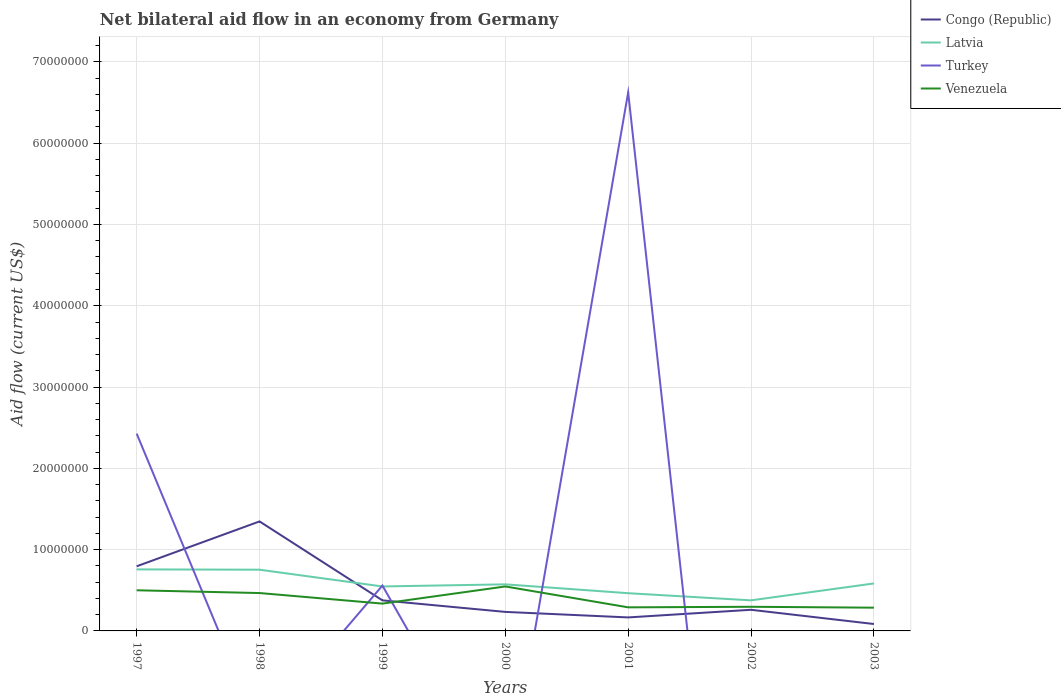Does the line corresponding to Latvia intersect with the line corresponding to Venezuela?
Offer a very short reply. No. Across all years, what is the maximum net bilateral aid flow in Latvia?
Make the answer very short. 3.76e+06. What is the total net bilateral aid flow in Venezuela in the graph?
Make the answer very short. 2.57e+06. What is the difference between the highest and the second highest net bilateral aid flow in Venezuela?
Your response must be concise. 2.61e+06. What is the difference between the highest and the lowest net bilateral aid flow in Congo (Republic)?
Make the answer very short. 2. Is the net bilateral aid flow in Venezuela strictly greater than the net bilateral aid flow in Congo (Republic) over the years?
Your answer should be very brief. No. Are the values on the major ticks of Y-axis written in scientific E-notation?
Provide a short and direct response. No. Where does the legend appear in the graph?
Your answer should be compact. Top right. What is the title of the graph?
Keep it short and to the point. Net bilateral aid flow in an economy from Germany. Does "Italy" appear as one of the legend labels in the graph?
Make the answer very short. No. What is the label or title of the Y-axis?
Ensure brevity in your answer.  Aid flow (current US$). What is the Aid flow (current US$) in Congo (Republic) in 1997?
Make the answer very short. 7.95e+06. What is the Aid flow (current US$) in Latvia in 1997?
Offer a terse response. 7.57e+06. What is the Aid flow (current US$) in Turkey in 1997?
Offer a terse response. 2.43e+07. What is the Aid flow (current US$) in Venezuela in 1997?
Provide a short and direct response. 5.00e+06. What is the Aid flow (current US$) in Congo (Republic) in 1998?
Ensure brevity in your answer.  1.35e+07. What is the Aid flow (current US$) in Latvia in 1998?
Provide a short and direct response. 7.53e+06. What is the Aid flow (current US$) of Turkey in 1998?
Your response must be concise. 0. What is the Aid flow (current US$) of Venezuela in 1998?
Give a very brief answer. 4.66e+06. What is the Aid flow (current US$) of Congo (Republic) in 1999?
Provide a succinct answer. 3.76e+06. What is the Aid flow (current US$) in Latvia in 1999?
Give a very brief answer. 5.47e+06. What is the Aid flow (current US$) in Turkey in 1999?
Your answer should be very brief. 5.58e+06. What is the Aid flow (current US$) of Venezuela in 1999?
Make the answer very short. 3.36e+06. What is the Aid flow (current US$) in Congo (Republic) in 2000?
Provide a short and direct response. 2.34e+06. What is the Aid flow (current US$) in Latvia in 2000?
Make the answer very short. 5.73e+06. What is the Aid flow (current US$) of Turkey in 2000?
Your response must be concise. 0. What is the Aid flow (current US$) in Venezuela in 2000?
Keep it short and to the point. 5.47e+06. What is the Aid flow (current US$) in Congo (Republic) in 2001?
Provide a succinct answer. 1.66e+06. What is the Aid flow (current US$) in Latvia in 2001?
Provide a succinct answer. 4.64e+06. What is the Aid flow (current US$) of Turkey in 2001?
Your response must be concise. 6.62e+07. What is the Aid flow (current US$) in Venezuela in 2001?
Provide a succinct answer. 2.90e+06. What is the Aid flow (current US$) in Congo (Republic) in 2002?
Your answer should be very brief. 2.60e+06. What is the Aid flow (current US$) of Latvia in 2002?
Your answer should be compact. 3.76e+06. What is the Aid flow (current US$) of Turkey in 2002?
Your answer should be very brief. 0. What is the Aid flow (current US$) in Venezuela in 2002?
Your answer should be compact. 2.97e+06. What is the Aid flow (current US$) in Congo (Republic) in 2003?
Your answer should be very brief. 8.50e+05. What is the Aid flow (current US$) of Latvia in 2003?
Your answer should be compact. 5.84e+06. What is the Aid flow (current US$) of Turkey in 2003?
Provide a succinct answer. 0. What is the Aid flow (current US$) of Venezuela in 2003?
Offer a terse response. 2.86e+06. Across all years, what is the maximum Aid flow (current US$) in Congo (Republic)?
Offer a terse response. 1.35e+07. Across all years, what is the maximum Aid flow (current US$) in Latvia?
Ensure brevity in your answer.  7.57e+06. Across all years, what is the maximum Aid flow (current US$) of Turkey?
Your response must be concise. 6.62e+07. Across all years, what is the maximum Aid flow (current US$) of Venezuela?
Offer a terse response. 5.47e+06. Across all years, what is the minimum Aid flow (current US$) of Congo (Republic)?
Provide a succinct answer. 8.50e+05. Across all years, what is the minimum Aid flow (current US$) in Latvia?
Your response must be concise. 3.76e+06. Across all years, what is the minimum Aid flow (current US$) of Turkey?
Your response must be concise. 0. Across all years, what is the minimum Aid flow (current US$) of Venezuela?
Ensure brevity in your answer.  2.86e+06. What is the total Aid flow (current US$) of Congo (Republic) in the graph?
Keep it short and to the point. 3.26e+07. What is the total Aid flow (current US$) of Latvia in the graph?
Give a very brief answer. 4.05e+07. What is the total Aid flow (current US$) in Turkey in the graph?
Your response must be concise. 9.61e+07. What is the total Aid flow (current US$) in Venezuela in the graph?
Give a very brief answer. 2.72e+07. What is the difference between the Aid flow (current US$) in Congo (Republic) in 1997 and that in 1998?
Provide a short and direct response. -5.52e+06. What is the difference between the Aid flow (current US$) in Venezuela in 1997 and that in 1998?
Ensure brevity in your answer.  3.40e+05. What is the difference between the Aid flow (current US$) in Congo (Republic) in 1997 and that in 1999?
Your response must be concise. 4.19e+06. What is the difference between the Aid flow (current US$) of Latvia in 1997 and that in 1999?
Provide a succinct answer. 2.10e+06. What is the difference between the Aid flow (current US$) in Turkey in 1997 and that in 1999?
Offer a terse response. 1.87e+07. What is the difference between the Aid flow (current US$) in Venezuela in 1997 and that in 1999?
Your answer should be compact. 1.64e+06. What is the difference between the Aid flow (current US$) in Congo (Republic) in 1997 and that in 2000?
Your answer should be compact. 5.61e+06. What is the difference between the Aid flow (current US$) in Latvia in 1997 and that in 2000?
Your answer should be compact. 1.84e+06. What is the difference between the Aid flow (current US$) in Venezuela in 1997 and that in 2000?
Your response must be concise. -4.70e+05. What is the difference between the Aid flow (current US$) in Congo (Republic) in 1997 and that in 2001?
Provide a short and direct response. 6.29e+06. What is the difference between the Aid flow (current US$) of Latvia in 1997 and that in 2001?
Keep it short and to the point. 2.93e+06. What is the difference between the Aid flow (current US$) in Turkey in 1997 and that in 2001?
Offer a terse response. -4.20e+07. What is the difference between the Aid flow (current US$) of Venezuela in 1997 and that in 2001?
Provide a short and direct response. 2.10e+06. What is the difference between the Aid flow (current US$) in Congo (Republic) in 1997 and that in 2002?
Your answer should be compact. 5.35e+06. What is the difference between the Aid flow (current US$) of Latvia in 1997 and that in 2002?
Provide a succinct answer. 3.81e+06. What is the difference between the Aid flow (current US$) in Venezuela in 1997 and that in 2002?
Your answer should be compact. 2.03e+06. What is the difference between the Aid flow (current US$) in Congo (Republic) in 1997 and that in 2003?
Your answer should be very brief. 7.10e+06. What is the difference between the Aid flow (current US$) of Latvia in 1997 and that in 2003?
Your answer should be very brief. 1.73e+06. What is the difference between the Aid flow (current US$) of Venezuela in 1997 and that in 2003?
Give a very brief answer. 2.14e+06. What is the difference between the Aid flow (current US$) of Congo (Republic) in 1998 and that in 1999?
Offer a terse response. 9.71e+06. What is the difference between the Aid flow (current US$) of Latvia in 1998 and that in 1999?
Your response must be concise. 2.06e+06. What is the difference between the Aid flow (current US$) of Venezuela in 1998 and that in 1999?
Your answer should be compact. 1.30e+06. What is the difference between the Aid flow (current US$) in Congo (Republic) in 1998 and that in 2000?
Your answer should be very brief. 1.11e+07. What is the difference between the Aid flow (current US$) in Latvia in 1998 and that in 2000?
Make the answer very short. 1.80e+06. What is the difference between the Aid flow (current US$) in Venezuela in 1998 and that in 2000?
Your answer should be compact. -8.10e+05. What is the difference between the Aid flow (current US$) of Congo (Republic) in 1998 and that in 2001?
Your answer should be very brief. 1.18e+07. What is the difference between the Aid flow (current US$) of Latvia in 1998 and that in 2001?
Your response must be concise. 2.89e+06. What is the difference between the Aid flow (current US$) of Venezuela in 1998 and that in 2001?
Provide a succinct answer. 1.76e+06. What is the difference between the Aid flow (current US$) of Congo (Republic) in 1998 and that in 2002?
Give a very brief answer. 1.09e+07. What is the difference between the Aid flow (current US$) of Latvia in 1998 and that in 2002?
Provide a short and direct response. 3.77e+06. What is the difference between the Aid flow (current US$) of Venezuela in 1998 and that in 2002?
Offer a very short reply. 1.69e+06. What is the difference between the Aid flow (current US$) of Congo (Republic) in 1998 and that in 2003?
Make the answer very short. 1.26e+07. What is the difference between the Aid flow (current US$) in Latvia in 1998 and that in 2003?
Ensure brevity in your answer.  1.69e+06. What is the difference between the Aid flow (current US$) of Venezuela in 1998 and that in 2003?
Provide a succinct answer. 1.80e+06. What is the difference between the Aid flow (current US$) of Congo (Republic) in 1999 and that in 2000?
Make the answer very short. 1.42e+06. What is the difference between the Aid flow (current US$) in Latvia in 1999 and that in 2000?
Make the answer very short. -2.60e+05. What is the difference between the Aid flow (current US$) of Venezuela in 1999 and that in 2000?
Provide a short and direct response. -2.11e+06. What is the difference between the Aid flow (current US$) of Congo (Republic) in 1999 and that in 2001?
Keep it short and to the point. 2.10e+06. What is the difference between the Aid flow (current US$) in Latvia in 1999 and that in 2001?
Offer a terse response. 8.30e+05. What is the difference between the Aid flow (current US$) of Turkey in 1999 and that in 2001?
Your response must be concise. -6.07e+07. What is the difference between the Aid flow (current US$) in Venezuela in 1999 and that in 2001?
Your answer should be very brief. 4.60e+05. What is the difference between the Aid flow (current US$) in Congo (Republic) in 1999 and that in 2002?
Provide a short and direct response. 1.16e+06. What is the difference between the Aid flow (current US$) in Latvia in 1999 and that in 2002?
Your response must be concise. 1.71e+06. What is the difference between the Aid flow (current US$) of Venezuela in 1999 and that in 2002?
Provide a short and direct response. 3.90e+05. What is the difference between the Aid flow (current US$) in Congo (Republic) in 1999 and that in 2003?
Your response must be concise. 2.91e+06. What is the difference between the Aid flow (current US$) in Latvia in 1999 and that in 2003?
Offer a terse response. -3.70e+05. What is the difference between the Aid flow (current US$) in Venezuela in 1999 and that in 2003?
Give a very brief answer. 5.00e+05. What is the difference between the Aid flow (current US$) in Congo (Republic) in 2000 and that in 2001?
Your answer should be very brief. 6.80e+05. What is the difference between the Aid flow (current US$) in Latvia in 2000 and that in 2001?
Your response must be concise. 1.09e+06. What is the difference between the Aid flow (current US$) in Venezuela in 2000 and that in 2001?
Ensure brevity in your answer.  2.57e+06. What is the difference between the Aid flow (current US$) of Latvia in 2000 and that in 2002?
Keep it short and to the point. 1.97e+06. What is the difference between the Aid flow (current US$) of Venezuela in 2000 and that in 2002?
Your answer should be compact. 2.50e+06. What is the difference between the Aid flow (current US$) of Congo (Republic) in 2000 and that in 2003?
Make the answer very short. 1.49e+06. What is the difference between the Aid flow (current US$) of Venezuela in 2000 and that in 2003?
Make the answer very short. 2.61e+06. What is the difference between the Aid flow (current US$) in Congo (Republic) in 2001 and that in 2002?
Offer a very short reply. -9.40e+05. What is the difference between the Aid flow (current US$) in Latvia in 2001 and that in 2002?
Keep it short and to the point. 8.80e+05. What is the difference between the Aid flow (current US$) in Congo (Republic) in 2001 and that in 2003?
Your answer should be compact. 8.10e+05. What is the difference between the Aid flow (current US$) in Latvia in 2001 and that in 2003?
Give a very brief answer. -1.20e+06. What is the difference between the Aid flow (current US$) in Venezuela in 2001 and that in 2003?
Make the answer very short. 4.00e+04. What is the difference between the Aid flow (current US$) in Congo (Republic) in 2002 and that in 2003?
Your answer should be very brief. 1.75e+06. What is the difference between the Aid flow (current US$) in Latvia in 2002 and that in 2003?
Make the answer very short. -2.08e+06. What is the difference between the Aid flow (current US$) of Congo (Republic) in 1997 and the Aid flow (current US$) of Latvia in 1998?
Ensure brevity in your answer.  4.20e+05. What is the difference between the Aid flow (current US$) in Congo (Republic) in 1997 and the Aid flow (current US$) in Venezuela in 1998?
Offer a very short reply. 3.29e+06. What is the difference between the Aid flow (current US$) of Latvia in 1997 and the Aid flow (current US$) of Venezuela in 1998?
Your answer should be compact. 2.91e+06. What is the difference between the Aid flow (current US$) in Turkey in 1997 and the Aid flow (current US$) in Venezuela in 1998?
Your answer should be compact. 1.96e+07. What is the difference between the Aid flow (current US$) of Congo (Republic) in 1997 and the Aid flow (current US$) of Latvia in 1999?
Provide a short and direct response. 2.48e+06. What is the difference between the Aid flow (current US$) in Congo (Republic) in 1997 and the Aid flow (current US$) in Turkey in 1999?
Make the answer very short. 2.37e+06. What is the difference between the Aid flow (current US$) in Congo (Republic) in 1997 and the Aid flow (current US$) in Venezuela in 1999?
Offer a very short reply. 4.59e+06. What is the difference between the Aid flow (current US$) in Latvia in 1997 and the Aid flow (current US$) in Turkey in 1999?
Give a very brief answer. 1.99e+06. What is the difference between the Aid flow (current US$) of Latvia in 1997 and the Aid flow (current US$) of Venezuela in 1999?
Your response must be concise. 4.21e+06. What is the difference between the Aid flow (current US$) in Turkey in 1997 and the Aid flow (current US$) in Venezuela in 1999?
Provide a short and direct response. 2.09e+07. What is the difference between the Aid flow (current US$) in Congo (Republic) in 1997 and the Aid flow (current US$) in Latvia in 2000?
Provide a short and direct response. 2.22e+06. What is the difference between the Aid flow (current US$) in Congo (Republic) in 1997 and the Aid flow (current US$) in Venezuela in 2000?
Offer a terse response. 2.48e+06. What is the difference between the Aid flow (current US$) of Latvia in 1997 and the Aid flow (current US$) of Venezuela in 2000?
Your answer should be very brief. 2.10e+06. What is the difference between the Aid flow (current US$) in Turkey in 1997 and the Aid flow (current US$) in Venezuela in 2000?
Ensure brevity in your answer.  1.88e+07. What is the difference between the Aid flow (current US$) of Congo (Republic) in 1997 and the Aid flow (current US$) of Latvia in 2001?
Offer a very short reply. 3.31e+06. What is the difference between the Aid flow (current US$) of Congo (Republic) in 1997 and the Aid flow (current US$) of Turkey in 2001?
Provide a short and direct response. -5.83e+07. What is the difference between the Aid flow (current US$) of Congo (Republic) in 1997 and the Aid flow (current US$) of Venezuela in 2001?
Ensure brevity in your answer.  5.05e+06. What is the difference between the Aid flow (current US$) in Latvia in 1997 and the Aid flow (current US$) in Turkey in 2001?
Your answer should be very brief. -5.87e+07. What is the difference between the Aid flow (current US$) in Latvia in 1997 and the Aid flow (current US$) in Venezuela in 2001?
Keep it short and to the point. 4.67e+06. What is the difference between the Aid flow (current US$) of Turkey in 1997 and the Aid flow (current US$) of Venezuela in 2001?
Your answer should be very brief. 2.14e+07. What is the difference between the Aid flow (current US$) in Congo (Republic) in 1997 and the Aid flow (current US$) in Latvia in 2002?
Your answer should be compact. 4.19e+06. What is the difference between the Aid flow (current US$) of Congo (Republic) in 1997 and the Aid flow (current US$) of Venezuela in 2002?
Provide a short and direct response. 4.98e+06. What is the difference between the Aid flow (current US$) of Latvia in 1997 and the Aid flow (current US$) of Venezuela in 2002?
Make the answer very short. 4.60e+06. What is the difference between the Aid flow (current US$) of Turkey in 1997 and the Aid flow (current US$) of Venezuela in 2002?
Keep it short and to the point. 2.13e+07. What is the difference between the Aid flow (current US$) in Congo (Republic) in 1997 and the Aid flow (current US$) in Latvia in 2003?
Give a very brief answer. 2.11e+06. What is the difference between the Aid flow (current US$) in Congo (Republic) in 1997 and the Aid flow (current US$) in Venezuela in 2003?
Your answer should be very brief. 5.09e+06. What is the difference between the Aid flow (current US$) in Latvia in 1997 and the Aid flow (current US$) in Venezuela in 2003?
Your response must be concise. 4.71e+06. What is the difference between the Aid flow (current US$) in Turkey in 1997 and the Aid flow (current US$) in Venezuela in 2003?
Provide a short and direct response. 2.14e+07. What is the difference between the Aid flow (current US$) in Congo (Republic) in 1998 and the Aid flow (current US$) in Latvia in 1999?
Give a very brief answer. 8.00e+06. What is the difference between the Aid flow (current US$) of Congo (Republic) in 1998 and the Aid flow (current US$) of Turkey in 1999?
Offer a terse response. 7.89e+06. What is the difference between the Aid flow (current US$) of Congo (Republic) in 1998 and the Aid flow (current US$) of Venezuela in 1999?
Ensure brevity in your answer.  1.01e+07. What is the difference between the Aid flow (current US$) of Latvia in 1998 and the Aid flow (current US$) of Turkey in 1999?
Provide a short and direct response. 1.95e+06. What is the difference between the Aid flow (current US$) of Latvia in 1998 and the Aid flow (current US$) of Venezuela in 1999?
Keep it short and to the point. 4.17e+06. What is the difference between the Aid flow (current US$) of Congo (Republic) in 1998 and the Aid flow (current US$) of Latvia in 2000?
Your answer should be compact. 7.74e+06. What is the difference between the Aid flow (current US$) of Congo (Republic) in 1998 and the Aid flow (current US$) of Venezuela in 2000?
Offer a very short reply. 8.00e+06. What is the difference between the Aid flow (current US$) of Latvia in 1998 and the Aid flow (current US$) of Venezuela in 2000?
Give a very brief answer. 2.06e+06. What is the difference between the Aid flow (current US$) in Congo (Republic) in 1998 and the Aid flow (current US$) in Latvia in 2001?
Make the answer very short. 8.83e+06. What is the difference between the Aid flow (current US$) in Congo (Republic) in 1998 and the Aid flow (current US$) in Turkey in 2001?
Make the answer very short. -5.28e+07. What is the difference between the Aid flow (current US$) of Congo (Republic) in 1998 and the Aid flow (current US$) of Venezuela in 2001?
Your answer should be very brief. 1.06e+07. What is the difference between the Aid flow (current US$) of Latvia in 1998 and the Aid flow (current US$) of Turkey in 2001?
Give a very brief answer. -5.87e+07. What is the difference between the Aid flow (current US$) in Latvia in 1998 and the Aid flow (current US$) in Venezuela in 2001?
Ensure brevity in your answer.  4.63e+06. What is the difference between the Aid flow (current US$) of Congo (Republic) in 1998 and the Aid flow (current US$) of Latvia in 2002?
Make the answer very short. 9.71e+06. What is the difference between the Aid flow (current US$) in Congo (Republic) in 1998 and the Aid flow (current US$) in Venezuela in 2002?
Ensure brevity in your answer.  1.05e+07. What is the difference between the Aid flow (current US$) in Latvia in 1998 and the Aid flow (current US$) in Venezuela in 2002?
Your answer should be very brief. 4.56e+06. What is the difference between the Aid flow (current US$) of Congo (Republic) in 1998 and the Aid flow (current US$) of Latvia in 2003?
Your answer should be very brief. 7.63e+06. What is the difference between the Aid flow (current US$) of Congo (Republic) in 1998 and the Aid flow (current US$) of Venezuela in 2003?
Offer a very short reply. 1.06e+07. What is the difference between the Aid flow (current US$) in Latvia in 1998 and the Aid flow (current US$) in Venezuela in 2003?
Ensure brevity in your answer.  4.67e+06. What is the difference between the Aid flow (current US$) in Congo (Republic) in 1999 and the Aid flow (current US$) in Latvia in 2000?
Offer a terse response. -1.97e+06. What is the difference between the Aid flow (current US$) in Congo (Republic) in 1999 and the Aid flow (current US$) in Venezuela in 2000?
Provide a short and direct response. -1.71e+06. What is the difference between the Aid flow (current US$) of Latvia in 1999 and the Aid flow (current US$) of Venezuela in 2000?
Provide a succinct answer. 0. What is the difference between the Aid flow (current US$) of Turkey in 1999 and the Aid flow (current US$) of Venezuela in 2000?
Your answer should be very brief. 1.10e+05. What is the difference between the Aid flow (current US$) of Congo (Republic) in 1999 and the Aid flow (current US$) of Latvia in 2001?
Your response must be concise. -8.80e+05. What is the difference between the Aid flow (current US$) of Congo (Republic) in 1999 and the Aid flow (current US$) of Turkey in 2001?
Offer a very short reply. -6.25e+07. What is the difference between the Aid flow (current US$) in Congo (Republic) in 1999 and the Aid flow (current US$) in Venezuela in 2001?
Offer a very short reply. 8.60e+05. What is the difference between the Aid flow (current US$) of Latvia in 1999 and the Aid flow (current US$) of Turkey in 2001?
Your answer should be compact. -6.08e+07. What is the difference between the Aid flow (current US$) in Latvia in 1999 and the Aid flow (current US$) in Venezuela in 2001?
Your answer should be compact. 2.57e+06. What is the difference between the Aid flow (current US$) in Turkey in 1999 and the Aid flow (current US$) in Venezuela in 2001?
Your answer should be very brief. 2.68e+06. What is the difference between the Aid flow (current US$) of Congo (Republic) in 1999 and the Aid flow (current US$) of Latvia in 2002?
Ensure brevity in your answer.  0. What is the difference between the Aid flow (current US$) in Congo (Republic) in 1999 and the Aid flow (current US$) in Venezuela in 2002?
Keep it short and to the point. 7.90e+05. What is the difference between the Aid flow (current US$) in Latvia in 1999 and the Aid flow (current US$) in Venezuela in 2002?
Your answer should be compact. 2.50e+06. What is the difference between the Aid flow (current US$) in Turkey in 1999 and the Aid flow (current US$) in Venezuela in 2002?
Offer a terse response. 2.61e+06. What is the difference between the Aid flow (current US$) of Congo (Republic) in 1999 and the Aid flow (current US$) of Latvia in 2003?
Your answer should be compact. -2.08e+06. What is the difference between the Aid flow (current US$) of Latvia in 1999 and the Aid flow (current US$) of Venezuela in 2003?
Your answer should be compact. 2.61e+06. What is the difference between the Aid flow (current US$) of Turkey in 1999 and the Aid flow (current US$) of Venezuela in 2003?
Provide a short and direct response. 2.72e+06. What is the difference between the Aid flow (current US$) of Congo (Republic) in 2000 and the Aid flow (current US$) of Latvia in 2001?
Your answer should be very brief. -2.30e+06. What is the difference between the Aid flow (current US$) of Congo (Republic) in 2000 and the Aid flow (current US$) of Turkey in 2001?
Keep it short and to the point. -6.39e+07. What is the difference between the Aid flow (current US$) of Congo (Republic) in 2000 and the Aid flow (current US$) of Venezuela in 2001?
Make the answer very short. -5.60e+05. What is the difference between the Aid flow (current US$) in Latvia in 2000 and the Aid flow (current US$) in Turkey in 2001?
Ensure brevity in your answer.  -6.05e+07. What is the difference between the Aid flow (current US$) in Latvia in 2000 and the Aid flow (current US$) in Venezuela in 2001?
Provide a succinct answer. 2.83e+06. What is the difference between the Aid flow (current US$) in Congo (Republic) in 2000 and the Aid flow (current US$) in Latvia in 2002?
Provide a succinct answer. -1.42e+06. What is the difference between the Aid flow (current US$) in Congo (Republic) in 2000 and the Aid flow (current US$) in Venezuela in 2002?
Give a very brief answer. -6.30e+05. What is the difference between the Aid flow (current US$) of Latvia in 2000 and the Aid flow (current US$) of Venezuela in 2002?
Your response must be concise. 2.76e+06. What is the difference between the Aid flow (current US$) in Congo (Republic) in 2000 and the Aid flow (current US$) in Latvia in 2003?
Your answer should be very brief. -3.50e+06. What is the difference between the Aid flow (current US$) of Congo (Republic) in 2000 and the Aid flow (current US$) of Venezuela in 2003?
Your answer should be very brief. -5.20e+05. What is the difference between the Aid flow (current US$) of Latvia in 2000 and the Aid flow (current US$) of Venezuela in 2003?
Your answer should be very brief. 2.87e+06. What is the difference between the Aid flow (current US$) in Congo (Republic) in 2001 and the Aid flow (current US$) in Latvia in 2002?
Provide a short and direct response. -2.10e+06. What is the difference between the Aid flow (current US$) in Congo (Republic) in 2001 and the Aid flow (current US$) in Venezuela in 2002?
Your answer should be very brief. -1.31e+06. What is the difference between the Aid flow (current US$) of Latvia in 2001 and the Aid flow (current US$) of Venezuela in 2002?
Provide a succinct answer. 1.67e+06. What is the difference between the Aid flow (current US$) in Turkey in 2001 and the Aid flow (current US$) in Venezuela in 2002?
Provide a succinct answer. 6.33e+07. What is the difference between the Aid flow (current US$) in Congo (Republic) in 2001 and the Aid flow (current US$) in Latvia in 2003?
Your answer should be very brief. -4.18e+06. What is the difference between the Aid flow (current US$) in Congo (Republic) in 2001 and the Aid flow (current US$) in Venezuela in 2003?
Offer a very short reply. -1.20e+06. What is the difference between the Aid flow (current US$) in Latvia in 2001 and the Aid flow (current US$) in Venezuela in 2003?
Your answer should be compact. 1.78e+06. What is the difference between the Aid flow (current US$) in Turkey in 2001 and the Aid flow (current US$) in Venezuela in 2003?
Your answer should be compact. 6.34e+07. What is the difference between the Aid flow (current US$) of Congo (Republic) in 2002 and the Aid flow (current US$) of Latvia in 2003?
Your response must be concise. -3.24e+06. What is the difference between the Aid flow (current US$) of Congo (Republic) in 2002 and the Aid flow (current US$) of Venezuela in 2003?
Give a very brief answer. -2.60e+05. What is the difference between the Aid flow (current US$) in Latvia in 2002 and the Aid flow (current US$) in Venezuela in 2003?
Provide a succinct answer. 9.00e+05. What is the average Aid flow (current US$) in Congo (Republic) per year?
Offer a terse response. 4.66e+06. What is the average Aid flow (current US$) of Latvia per year?
Provide a succinct answer. 5.79e+06. What is the average Aid flow (current US$) of Turkey per year?
Your answer should be very brief. 1.37e+07. What is the average Aid flow (current US$) of Venezuela per year?
Keep it short and to the point. 3.89e+06. In the year 1997, what is the difference between the Aid flow (current US$) in Congo (Republic) and Aid flow (current US$) in Turkey?
Offer a terse response. -1.63e+07. In the year 1997, what is the difference between the Aid flow (current US$) in Congo (Republic) and Aid flow (current US$) in Venezuela?
Provide a succinct answer. 2.95e+06. In the year 1997, what is the difference between the Aid flow (current US$) of Latvia and Aid flow (current US$) of Turkey?
Your answer should be compact. -1.67e+07. In the year 1997, what is the difference between the Aid flow (current US$) in Latvia and Aid flow (current US$) in Venezuela?
Your response must be concise. 2.57e+06. In the year 1997, what is the difference between the Aid flow (current US$) in Turkey and Aid flow (current US$) in Venezuela?
Offer a very short reply. 1.93e+07. In the year 1998, what is the difference between the Aid flow (current US$) in Congo (Republic) and Aid flow (current US$) in Latvia?
Your response must be concise. 5.94e+06. In the year 1998, what is the difference between the Aid flow (current US$) in Congo (Republic) and Aid flow (current US$) in Venezuela?
Your answer should be very brief. 8.81e+06. In the year 1998, what is the difference between the Aid flow (current US$) in Latvia and Aid flow (current US$) in Venezuela?
Your answer should be compact. 2.87e+06. In the year 1999, what is the difference between the Aid flow (current US$) in Congo (Republic) and Aid flow (current US$) in Latvia?
Provide a short and direct response. -1.71e+06. In the year 1999, what is the difference between the Aid flow (current US$) in Congo (Republic) and Aid flow (current US$) in Turkey?
Offer a terse response. -1.82e+06. In the year 1999, what is the difference between the Aid flow (current US$) in Latvia and Aid flow (current US$) in Turkey?
Keep it short and to the point. -1.10e+05. In the year 1999, what is the difference between the Aid flow (current US$) of Latvia and Aid flow (current US$) of Venezuela?
Your answer should be very brief. 2.11e+06. In the year 1999, what is the difference between the Aid flow (current US$) of Turkey and Aid flow (current US$) of Venezuela?
Your answer should be very brief. 2.22e+06. In the year 2000, what is the difference between the Aid flow (current US$) in Congo (Republic) and Aid flow (current US$) in Latvia?
Ensure brevity in your answer.  -3.39e+06. In the year 2000, what is the difference between the Aid flow (current US$) in Congo (Republic) and Aid flow (current US$) in Venezuela?
Offer a very short reply. -3.13e+06. In the year 2001, what is the difference between the Aid flow (current US$) of Congo (Republic) and Aid flow (current US$) of Latvia?
Offer a very short reply. -2.98e+06. In the year 2001, what is the difference between the Aid flow (current US$) in Congo (Republic) and Aid flow (current US$) in Turkey?
Make the answer very short. -6.46e+07. In the year 2001, what is the difference between the Aid flow (current US$) of Congo (Republic) and Aid flow (current US$) of Venezuela?
Offer a terse response. -1.24e+06. In the year 2001, what is the difference between the Aid flow (current US$) in Latvia and Aid flow (current US$) in Turkey?
Give a very brief answer. -6.16e+07. In the year 2001, what is the difference between the Aid flow (current US$) of Latvia and Aid flow (current US$) of Venezuela?
Make the answer very short. 1.74e+06. In the year 2001, what is the difference between the Aid flow (current US$) in Turkey and Aid flow (current US$) in Venezuela?
Offer a very short reply. 6.34e+07. In the year 2002, what is the difference between the Aid flow (current US$) of Congo (Republic) and Aid flow (current US$) of Latvia?
Offer a very short reply. -1.16e+06. In the year 2002, what is the difference between the Aid flow (current US$) in Congo (Republic) and Aid flow (current US$) in Venezuela?
Provide a short and direct response. -3.70e+05. In the year 2002, what is the difference between the Aid flow (current US$) of Latvia and Aid flow (current US$) of Venezuela?
Your answer should be very brief. 7.90e+05. In the year 2003, what is the difference between the Aid flow (current US$) of Congo (Republic) and Aid flow (current US$) of Latvia?
Provide a succinct answer. -4.99e+06. In the year 2003, what is the difference between the Aid flow (current US$) in Congo (Republic) and Aid flow (current US$) in Venezuela?
Provide a short and direct response. -2.01e+06. In the year 2003, what is the difference between the Aid flow (current US$) in Latvia and Aid flow (current US$) in Venezuela?
Provide a succinct answer. 2.98e+06. What is the ratio of the Aid flow (current US$) of Congo (Republic) in 1997 to that in 1998?
Give a very brief answer. 0.59. What is the ratio of the Aid flow (current US$) of Latvia in 1997 to that in 1998?
Provide a succinct answer. 1.01. What is the ratio of the Aid flow (current US$) of Venezuela in 1997 to that in 1998?
Make the answer very short. 1.07. What is the ratio of the Aid flow (current US$) of Congo (Republic) in 1997 to that in 1999?
Your answer should be very brief. 2.11. What is the ratio of the Aid flow (current US$) in Latvia in 1997 to that in 1999?
Your answer should be compact. 1.38. What is the ratio of the Aid flow (current US$) in Turkey in 1997 to that in 1999?
Provide a short and direct response. 4.35. What is the ratio of the Aid flow (current US$) in Venezuela in 1997 to that in 1999?
Offer a terse response. 1.49. What is the ratio of the Aid flow (current US$) of Congo (Republic) in 1997 to that in 2000?
Provide a succinct answer. 3.4. What is the ratio of the Aid flow (current US$) in Latvia in 1997 to that in 2000?
Ensure brevity in your answer.  1.32. What is the ratio of the Aid flow (current US$) in Venezuela in 1997 to that in 2000?
Your answer should be very brief. 0.91. What is the ratio of the Aid flow (current US$) of Congo (Republic) in 1997 to that in 2001?
Your response must be concise. 4.79. What is the ratio of the Aid flow (current US$) of Latvia in 1997 to that in 2001?
Your answer should be very brief. 1.63. What is the ratio of the Aid flow (current US$) of Turkey in 1997 to that in 2001?
Make the answer very short. 0.37. What is the ratio of the Aid flow (current US$) in Venezuela in 1997 to that in 2001?
Provide a short and direct response. 1.72. What is the ratio of the Aid flow (current US$) in Congo (Republic) in 1997 to that in 2002?
Give a very brief answer. 3.06. What is the ratio of the Aid flow (current US$) of Latvia in 1997 to that in 2002?
Provide a short and direct response. 2.01. What is the ratio of the Aid flow (current US$) in Venezuela in 1997 to that in 2002?
Keep it short and to the point. 1.68. What is the ratio of the Aid flow (current US$) in Congo (Republic) in 1997 to that in 2003?
Provide a succinct answer. 9.35. What is the ratio of the Aid flow (current US$) of Latvia in 1997 to that in 2003?
Your answer should be compact. 1.3. What is the ratio of the Aid flow (current US$) in Venezuela in 1997 to that in 2003?
Keep it short and to the point. 1.75. What is the ratio of the Aid flow (current US$) of Congo (Republic) in 1998 to that in 1999?
Ensure brevity in your answer.  3.58. What is the ratio of the Aid flow (current US$) of Latvia in 1998 to that in 1999?
Provide a succinct answer. 1.38. What is the ratio of the Aid flow (current US$) of Venezuela in 1998 to that in 1999?
Make the answer very short. 1.39. What is the ratio of the Aid flow (current US$) of Congo (Republic) in 1998 to that in 2000?
Offer a terse response. 5.76. What is the ratio of the Aid flow (current US$) of Latvia in 1998 to that in 2000?
Offer a terse response. 1.31. What is the ratio of the Aid flow (current US$) in Venezuela in 1998 to that in 2000?
Your answer should be compact. 0.85. What is the ratio of the Aid flow (current US$) of Congo (Republic) in 1998 to that in 2001?
Offer a very short reply. 8.11. What is the ratio of the Aid flow (current US$) in Latvia in 1998 to that in 2001?
Provide a short and direct response. 1.62. What is the ratio of the Aid flow (current US$) in Venezuela in 1998 to that in 2001?
Offer a terse response. 1.61. What is the ratio of the Aid flow (current US$) of Congo (Republic) in 1998 to that in 2002?
Your response must be concise. 5.18. What is the ratio of the Aid flow (current US$) of Latvia in 1998 to that in 2002?
Offer a very short reply. 2. What is the ratio of the Aid flow (current US$) of Venezuela in 1998 to that in 2002?
Keep it short and to the point. 1.57. What is the ratio of the Aid flow (current US$) in Congo (Republic) in 1998 to that in 2003?
Offer a terse response. 15.85. What is the ratio of the Aid flow (current US$) in Latvia in 1998 to that in 2003?
Your answer should be compact. 1.29. What is the ratio of the Aid flow (current US$) of Venezuela in 1998 to that in 2003?
Offer a terse response. 1.63. What is the ratio of the Aid flow (current US$) in Congo (Republic) in 1999 to that in 2000?
Ensure brevity in your answer.  1.61. What is the ratio of the Aid flow (current US$) of Latvia in 1999 to that in 2000?
Your answer should be compact. 0.95. What is the ratio of the Aid flow (current US$) of Venezuela in 1999 to that in 2000?
Provide a succinct answer. 0.61. What is the ratio of the Aid flow (current US$) of Congo (Republic) in 1999 to that in 2001?
Give a very brief answer. 2.27. What is the ratio of the Aid flow (current US$) in Latvia in 1999 to that in 2001?
Offer a terse response. 1.18. What is the ratio of the Aid flow (current US$) of Turkey in 1999 to that in 2001?
Your response must be concise. 0.08. What is the ratio of the Aid flow (current US$) of Venezuela in 1999 to that in 2001?
Provide a short and direct response. 1.16. What is the ratio of the Aid flow (current US$) of Congo (Republic) in 1999 to that in 2002?
Make the answer very short. 1.45. What is the ratio of the Aid flow (current US$) in Latvia in 1999 to that in 2002?
Ensure brevity in your answer.  1.45. What is the ratio of the Aid flow (current US$) in Venezuela in 1999 to that in 2002?
Offer a very short reply. 1.13. What is the ratio of the Aid flow (current US$) in Congo (Republic) in 1999 to that in 2003?
Your answer should be very brief. 4.42. What is the ratio of the Aid flow (current US$) in Latvia in 1999 to that in 2003?
Your answer should be compact. 0.94. What is the ratio of the Aid flow (current US$) in Venezuela in 1999 to that in 2003?
Your response must be concise. 1.17. What is the ratio of the Aid flow (current US$) of Congo (Republic) in 2000 to that in 2001?
Offer a very short reply. 1.41. What is the ratio of the Aid flow (current US$) of Latvia in 2000 to that in 2001?
Your answer should be very brief. 1.23. What is the ratio of the Aid flow (current US$) in Venezuela in 2000 to that in 2001?
Make the answer very short. 1.89. What is the ratio of the Aid flow (current US$) in Congo (Republic) in 2000 to that in 2002?
Make the answer very short. 0.9. What is the ratio of the Aid flow (current US$) in Latvia in 2000 to that in 2002?
Offer a terse response. 1.52. What is the ratio of the Aid flow (current US$) in Venezuela in 2000 to that in 2002?
Offer a very short reply. 1.84. What is the ratio of the Aid flow (current US$) in Congo (Republic) in 2000 to that in 2003?
Provide a short and direct response. 2.75. What is the ratio of the Aid flow (current US$) in Latvia in 2000 to that in 2003?
Provide a succinct answer. 0.98. What is the ratio of the Aid flow (current US$) of Venezuela in 2000 to that in 2003?
Offer a very short reply. 1.91. What is the ratio of the Aid flow (current US$) of Congo (Republic) in 2001 to that in 2002?
Provide a short and direct response. 0.64. What is the ratio of the Aid flow (current US$) in Latvia in 2001 to that in 2002?
Your answer should be compact. 1.23. What is the ratio of the Aid flow (current US$) in Venezuela in 2001 to that in 2002?
Provide a succinct answer. 0.98. What is the ratio of the Aid flow (current US$) of Congo (Republic) in 2001 to that in 2003?
Your answer should be compact. 1.95. What is the ratio of the Aid flow (current US$) in Latvia in 2001 to that in 2003?
Offer a very short reply. 0.79. What is the ratio of the Aid flow (current US$) of Venezuela in 2001 to that in 2003?
Ensure brevity in your answer.  1.01. What is the ratio of the Aid flow (current US$) in Congo (Republic) in 2002 to that in 2003?
Provide a succinct answer. 3.06. What is the ratio of the Aid flow (current US$) of Latvia in 2002 to that in 2003?
Your response must be concise. 0.64. What is the difference between the highest and the second highest Aid flow (current US$) of Congo (Republic)?
Your answer should be very brief. 5.52e+06. What is the difference between the highest and the second highest Aid flow (current US$) of Latvia?
Keep it short and to the point. 4.00e+04. What is the difference between the highest and the second highest Aid flow (current US$) of Turkey?
Provide a short and direct response. 4.20e+07. What is the difference between the highest and the lowest Aid flow (current US$) of Congo (Republic)?
Provide a succinct answer. 1.26e+07. What is the difference between the highest and the lowest Aid flow (current US$) in Latvia?
Provide a short and direct response. 3.81e+06. What is the difference between the highest and the lowest Aid flow (current US$) of Turkey?
Offer a very short reply. 6.62e+07. What is the difference between the highest and the lowest Aid flow (current US$) in Venezuela?
Ensure brevity in your answer.  2.61e+06. 